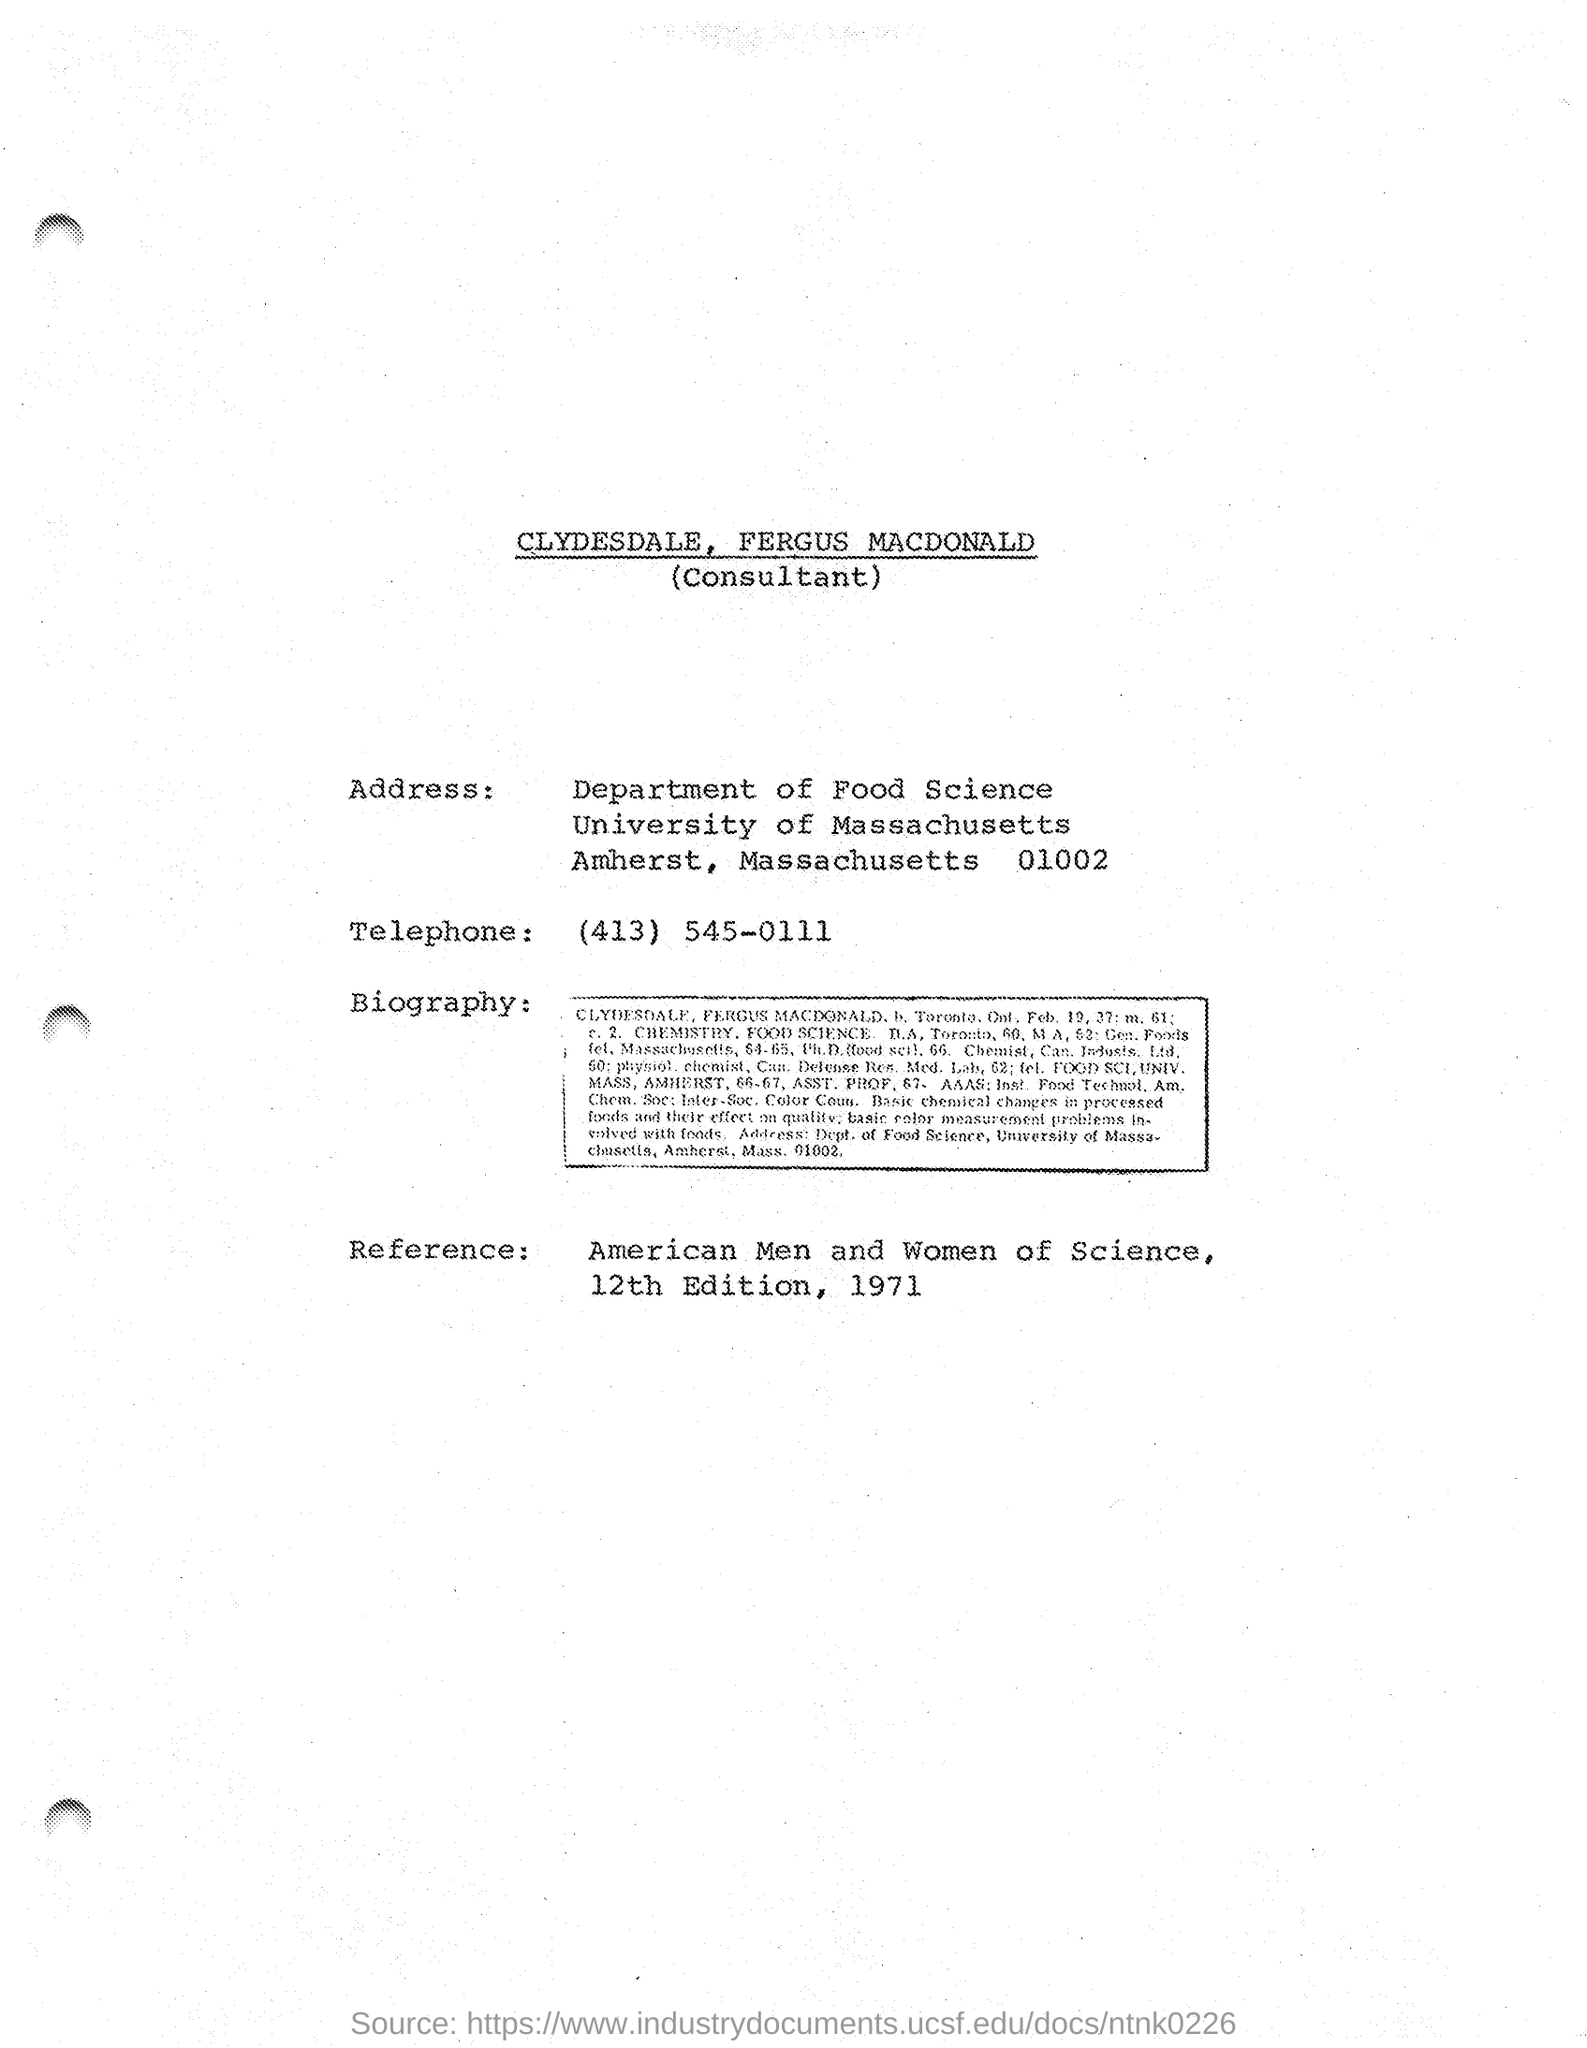Point out several critical features in this image. The telephone number provided on the given page is (413) 545-0111. The University of Massachusetts is the name of the university mentioned in the given address. The reference mentioned in the given page is "American Men and Women of Science, 12th edition, 1971. 